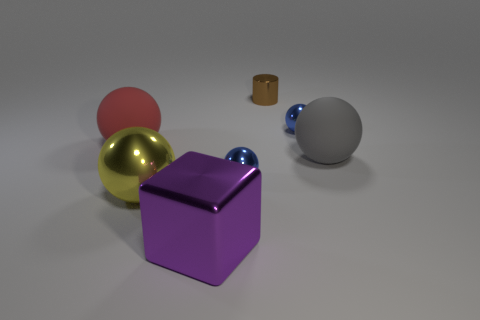Subtract all gray blocks. How many blue balls are left? 2 Subtract all large yellow balls. How many balls are left? 4 Subtract 3 balls. How many balls are left? 2 Subtract all gray spheres. How many spheres are left? 4 Add 1 purple objects. How many objects exist? 8 Subtract all cylinders. How many objects are left? 6 Subtract 0 blue blocks. How many objects are left? 7 Subtract all blue balls. Subtract all red cylinders. How many balls are left? 3 Subtract all gray rubber objects. Subtract all brown metal objects. How many objects are left? 5 Add 6 small blue shiny spheres. How many small blue shiny spheres are left? 8 